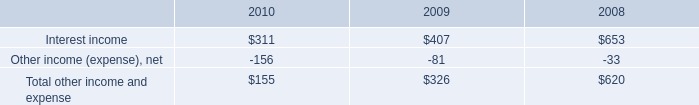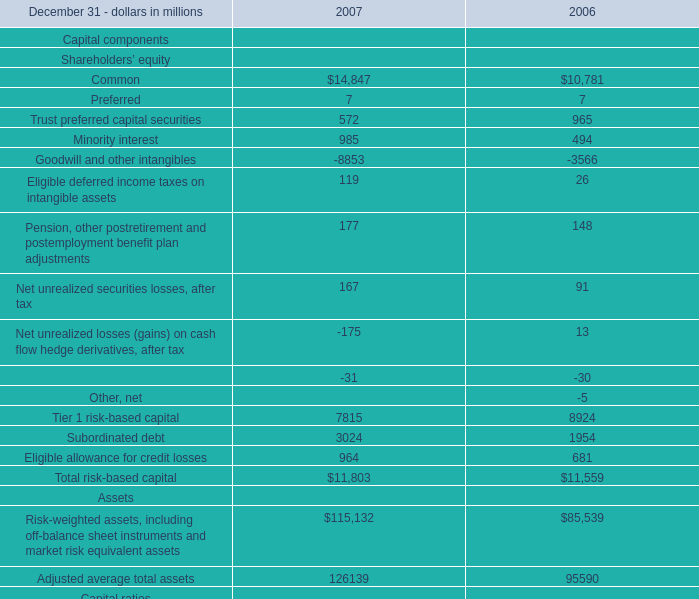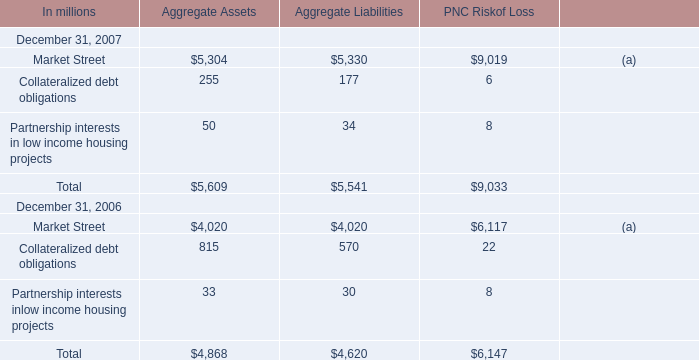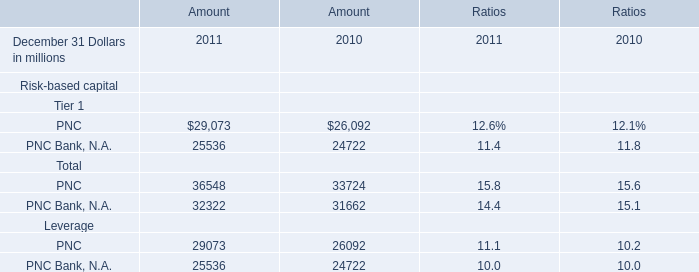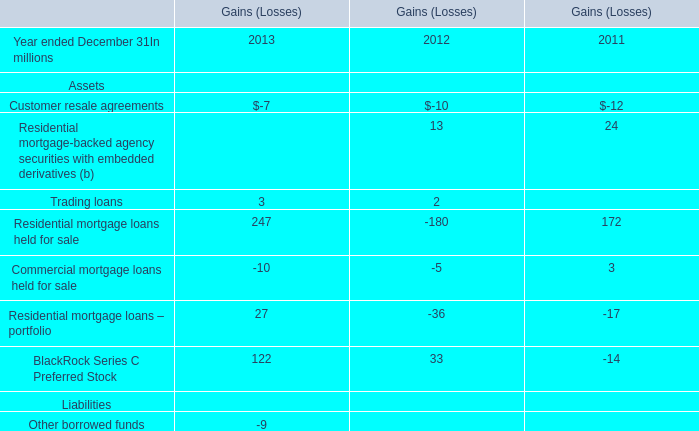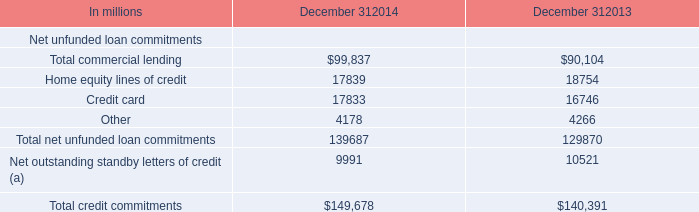What is the sum of Aggregate Liabilities in the range of 0 and 200 in 2007? (in million) 
Computations: (177 + 34)
Answer: 211.0. 